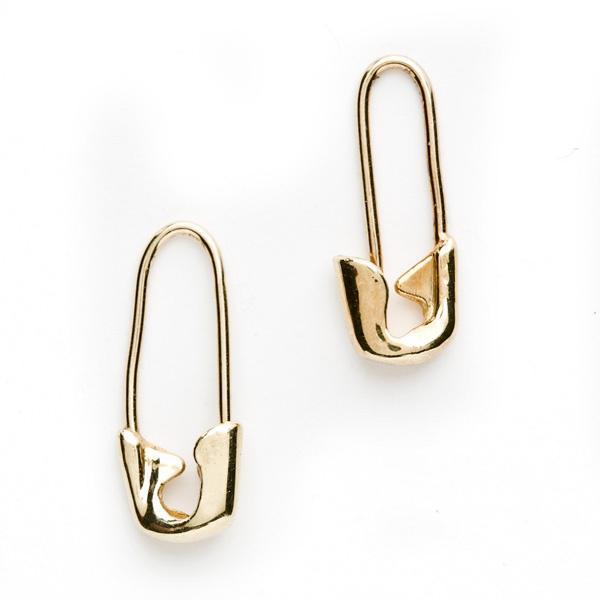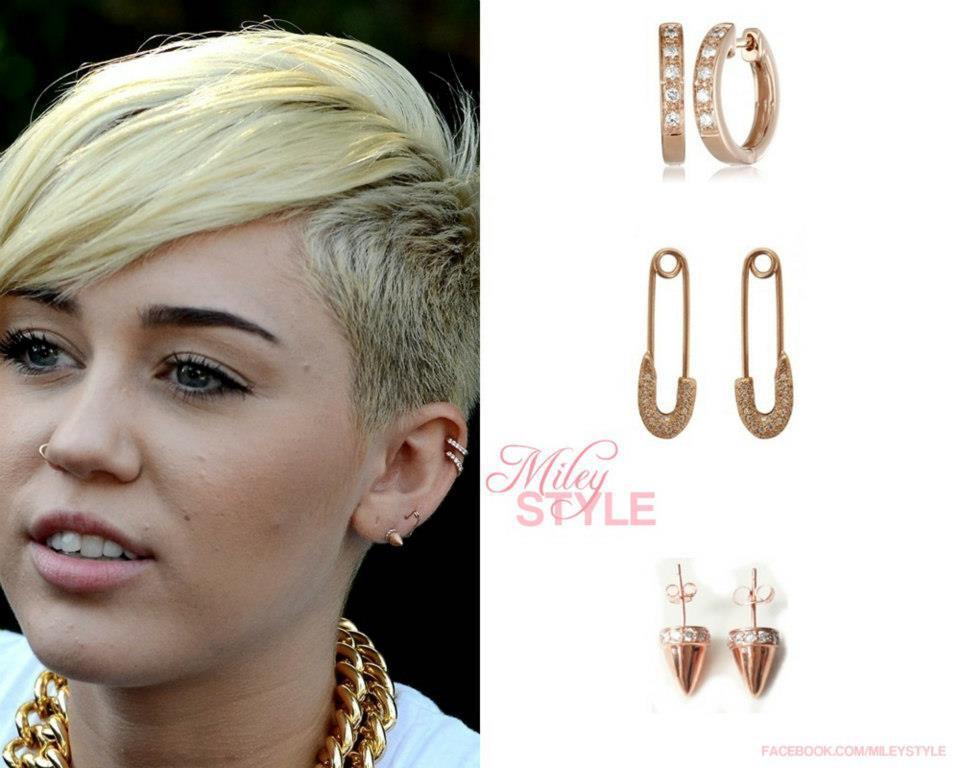The first image is the image on the left, the second image is the image on the right. Assess this claim about the two images: "At least one image includes a pair of closed, unembellished gold safety pins displayed with the clasp end downward.". Correct or not? Answer yes or no. Yes. 